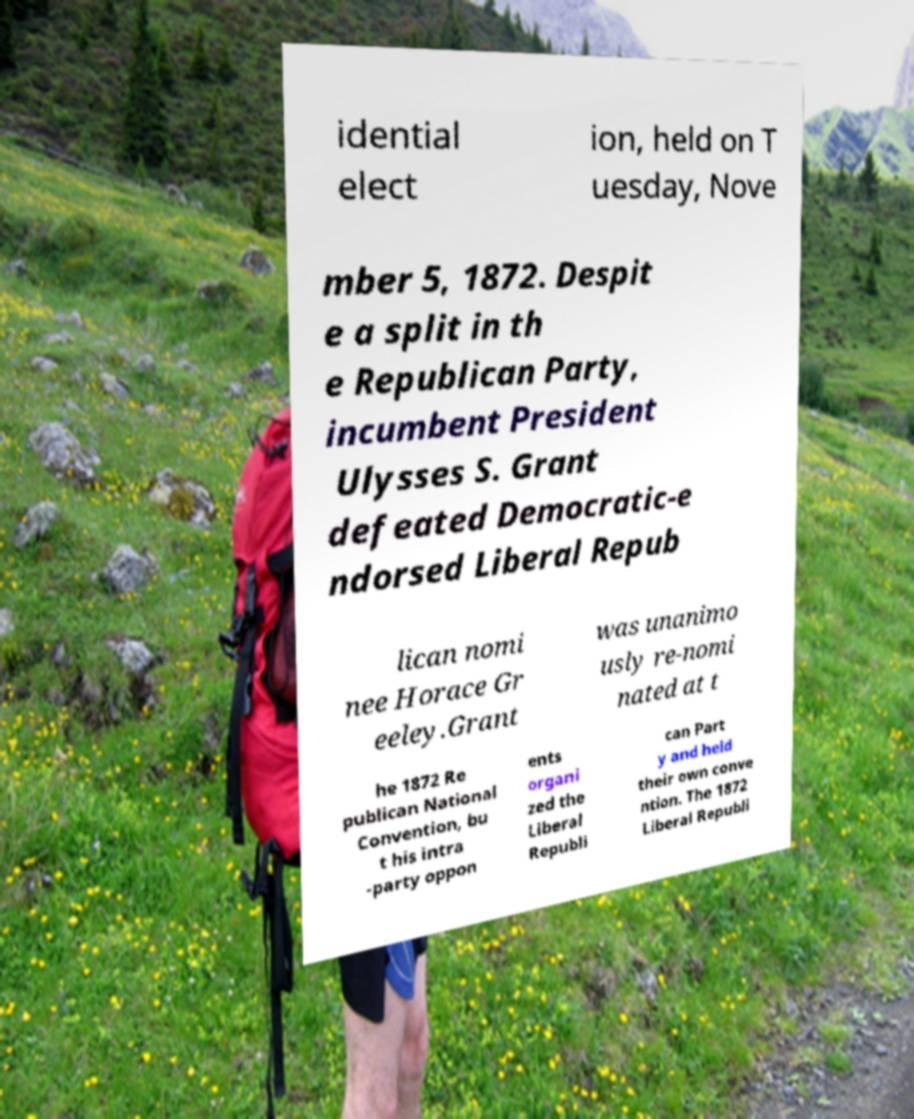Please read and relay the text visible in this image. What does it say? idential elect ion, held on T uesday, Nove mber 5, 1872. Despit e a split in th e Republican Party, incumbent President Ulysses S. Grant defeated Democratic-e ndorsed Liberal Repub lican nomi nee Horace Gr eeley.Grant was unanimo usly re-nomi nated at t he 1872 Re publican National Convention, bu t his intra -party oppon ents organi zed the Liberal Republi can Part y and held their own conve ntion. The 1872 Liberal Republi 